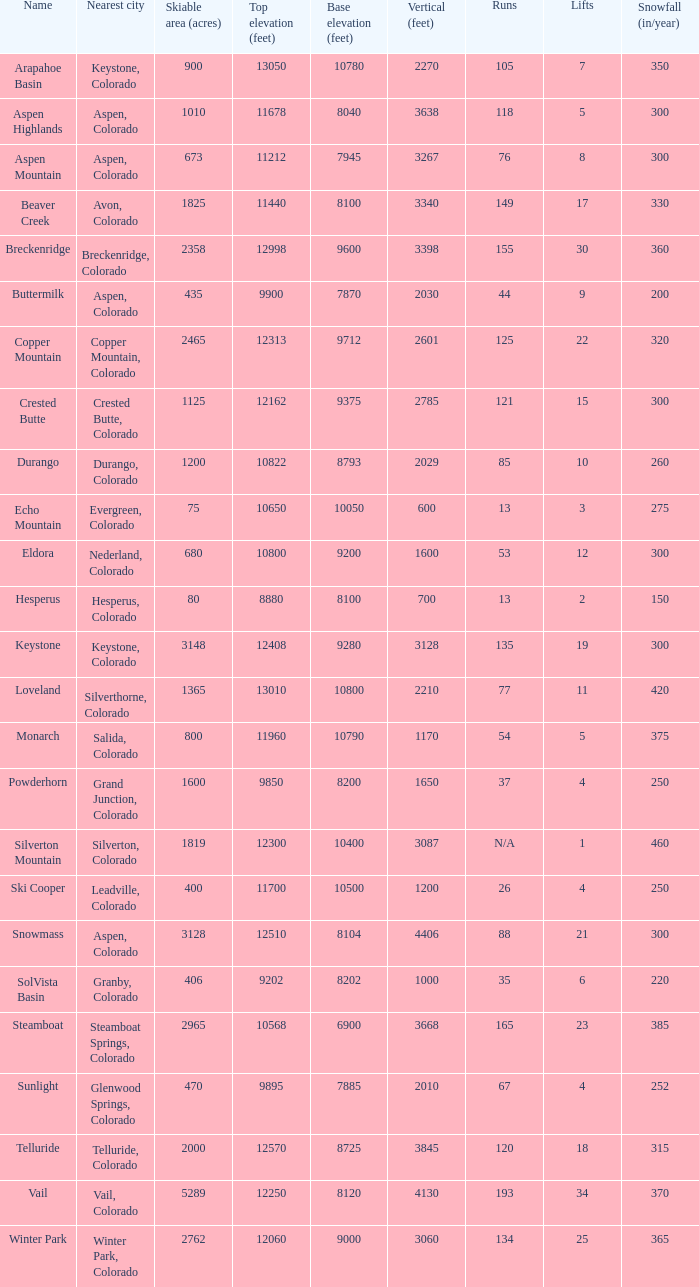How many resorts have 118 runs? 1.0. 